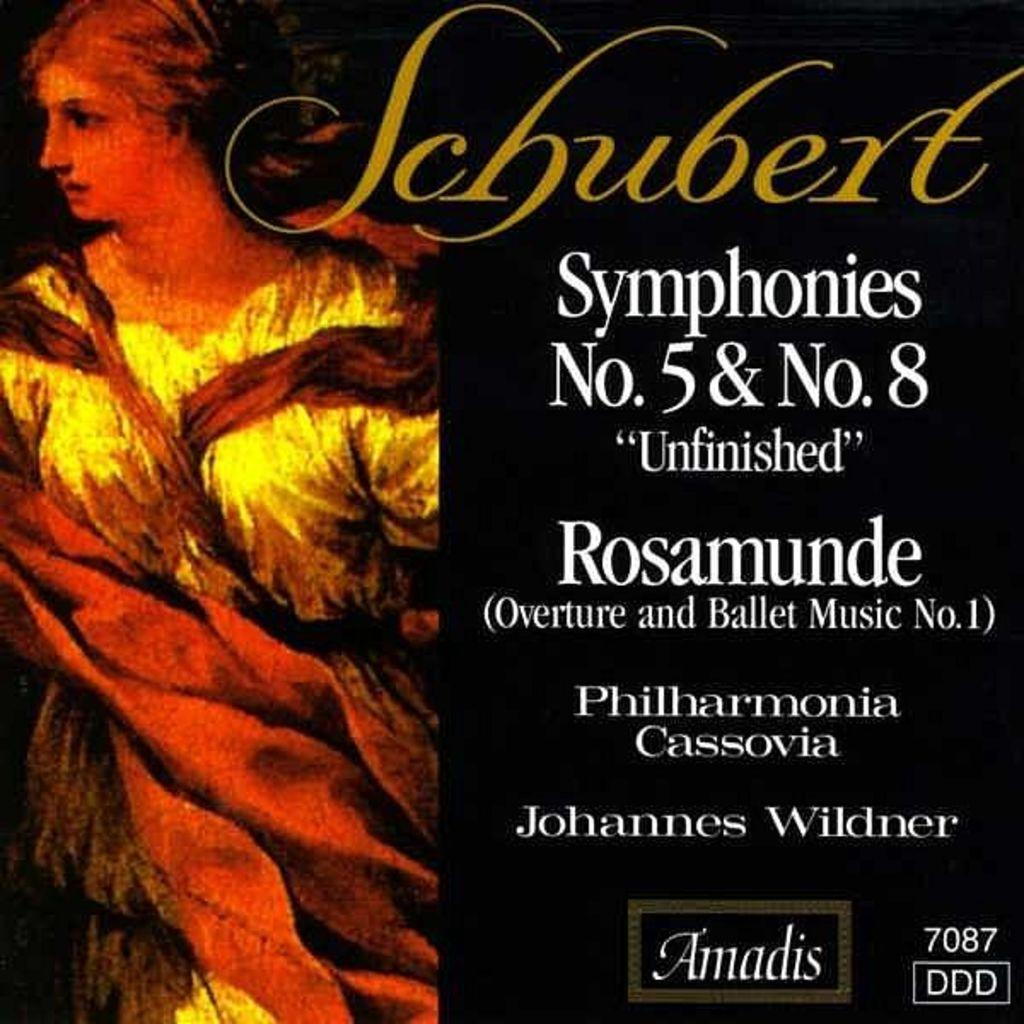<image>
Describe the image concisely. A black CD cover with the title of Schubert S Symphonies No. 5 & 8. 